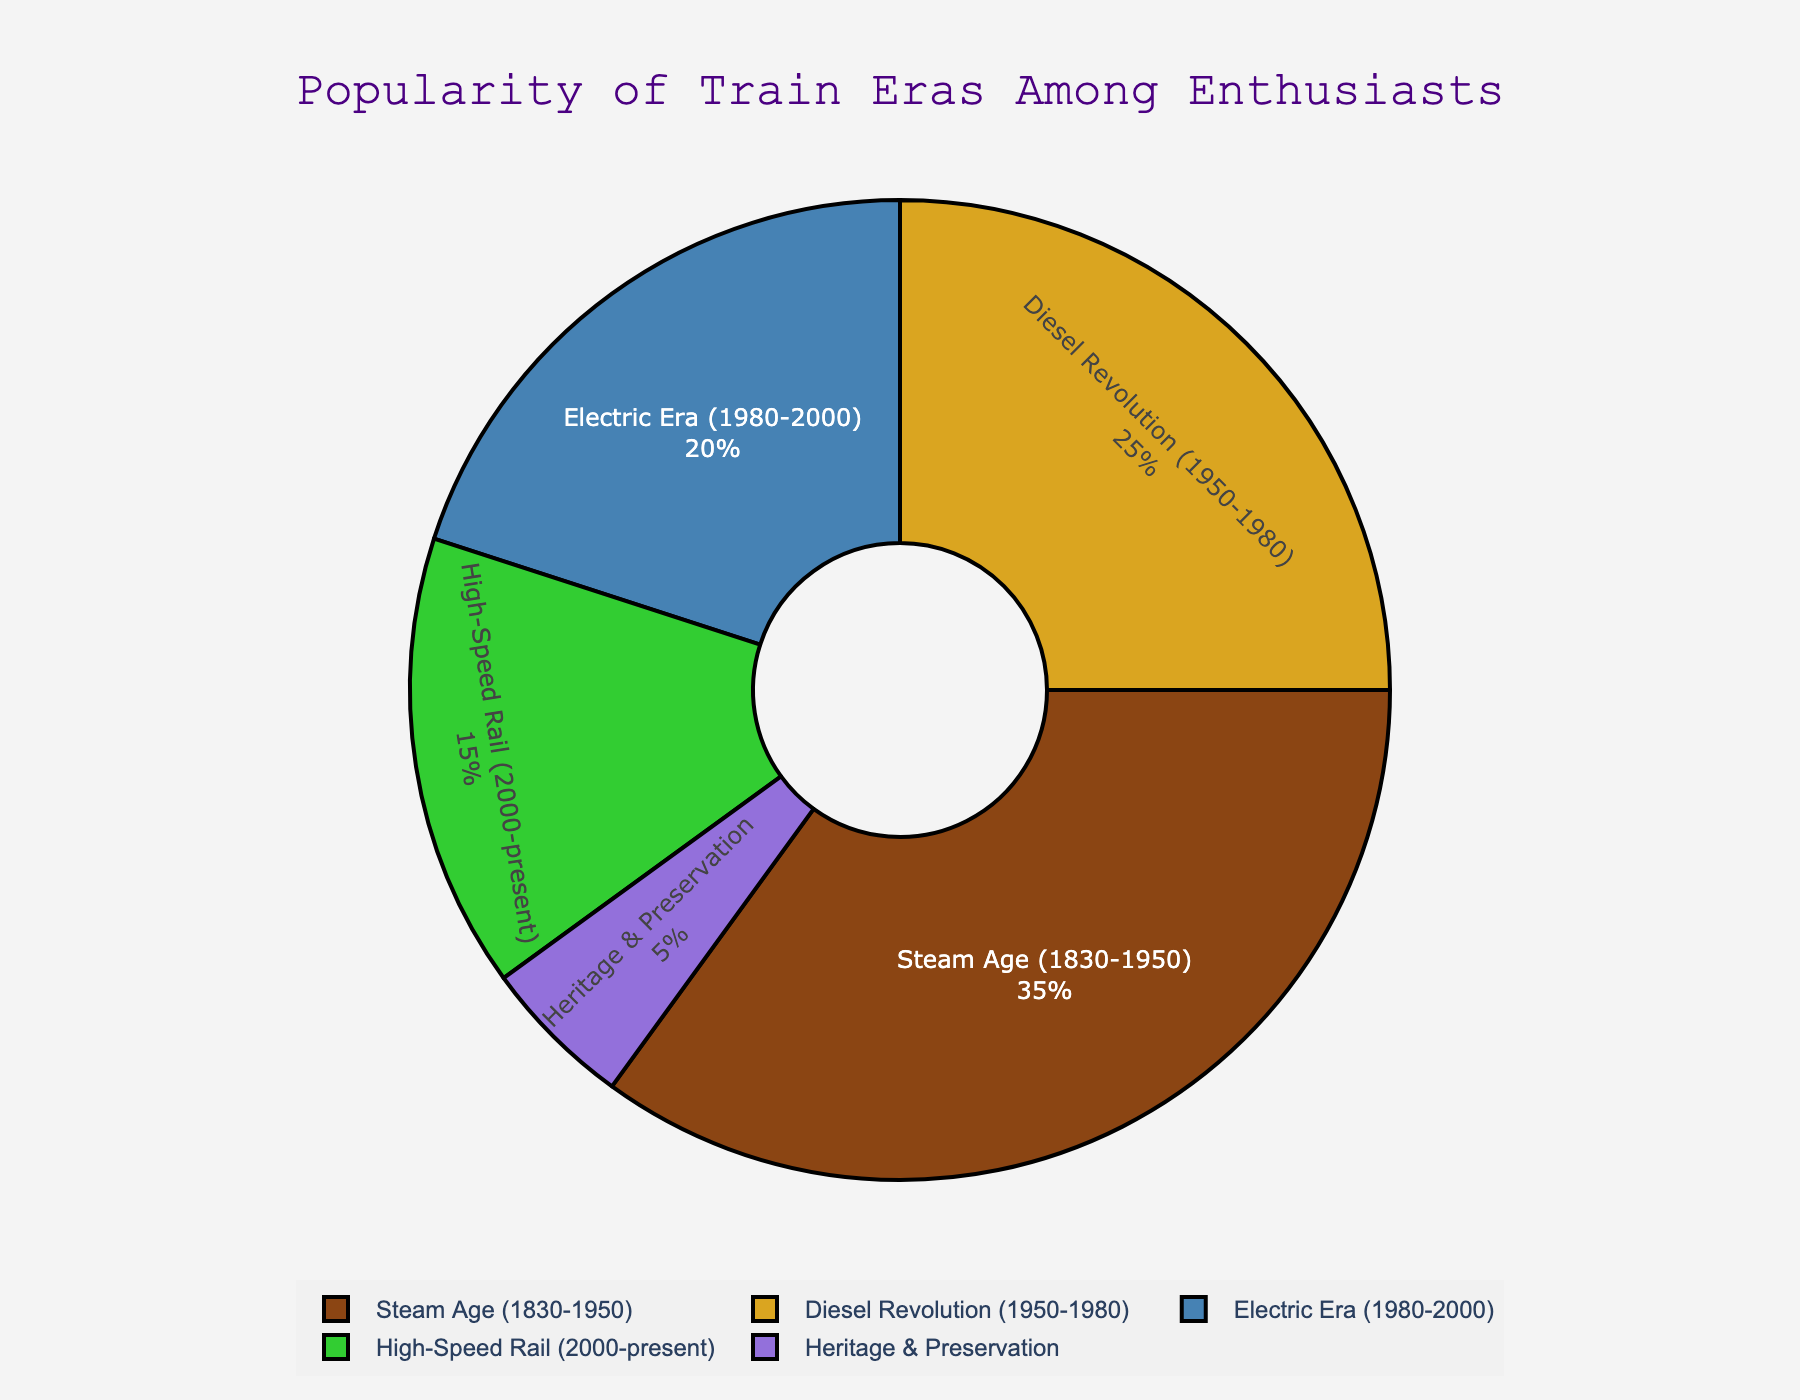what era has the highest popularity among train enthusiasts? The Steam Age (1830-1950) segment has the largest percentage value, making it the most popular era among train enthusiasts.
Answer: Steam Age (1830-1950) which era is least popular among train enthusiasts? The Heritage & Preservation segment has the smallest percentage value, indicating it is the least popular era among train enthusiasts.
Answer: Heritage & Preservation what is the combined popularity percentage of the Diesel Revolution (1950-1980) and Electric Era (1980-2000)? Add the percentages of Diesel Revolution (25%) and Electric Era (20%). 25 + 20 = 45.
Answer: 45 what is the difference in popularity percentage between the Steam Age (1830-1950) and High-Speed Rail (2000-present)? Subtract the percentage of High-Speed Rail (15%) from the percentage of Steam Age (35%). 35 - 15 = 20.
Answer: 20 which era is more popular: Electric Era (1980-2000) or High-Speed Rail (2000-present)? The percentage for the Electric Era (20%) is higher than that for High-Speed Rail (15%), indicating the Electric Era is more popular.
Answer: Electric Era (1980-2000) what is the total percentage of enthusiasts interested in eras before 2000? Add the percentages of Steam Age (35%), Diesel Revolution (25%), and Electric Era (20%). 35 + 25 + 20 = 80.
Answer: 80 what color represents the Diesel Revolution (1950-1980) era in the pie chart? Observing the chart, the Diesel Revolution (1950-1980) is represented by a golden brown color.
Answer: golden brown If translated into an exact number of enthusiasts, how many enthusiasts out of 100 would prefer the High-Speed Rail (2000-present) era? The percentage for High-Speed Rail (2000-present) is 15%. Out of 100 enthusiasts, 15% of 100 is 15.
Answer: 15 what is the average popularity percentage of all train eras except the Heritage & Preservation era? Add the percentages of all eras except Heritage & Preservation (Steam Age: 35%, Diesel Revolution: 25%, Electric Era: 20%, High-Speed Rail: 15%). Then divide by the number of these eras. (35 + 25 + 20 + 15) / 4 = 95 / 4 = 23.75.
Answer: 23.75 